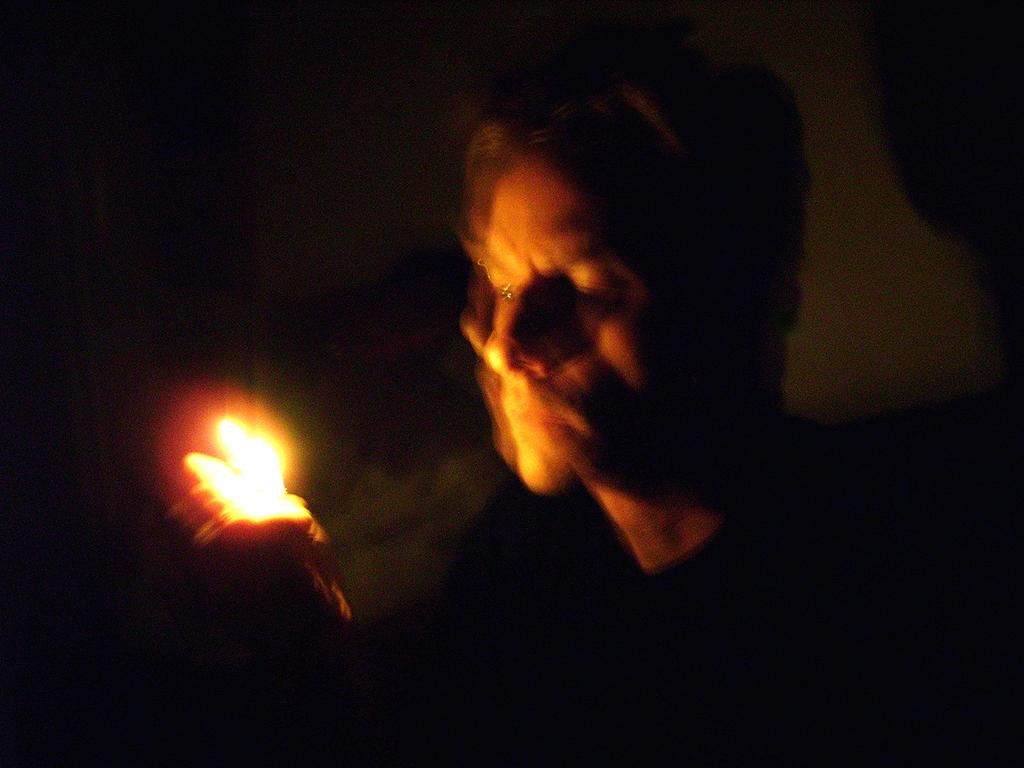What is the main subject of the image? There is a person in the image. What is the person holding in their hands? The person is holding a light in their hands. Can you tell me what type of cherries the person is holding in the image? There are no cherries present in the image; the person is holding a light. What hobbies does the person have, based on the image? The image does not provide information about the person's hobbies. 